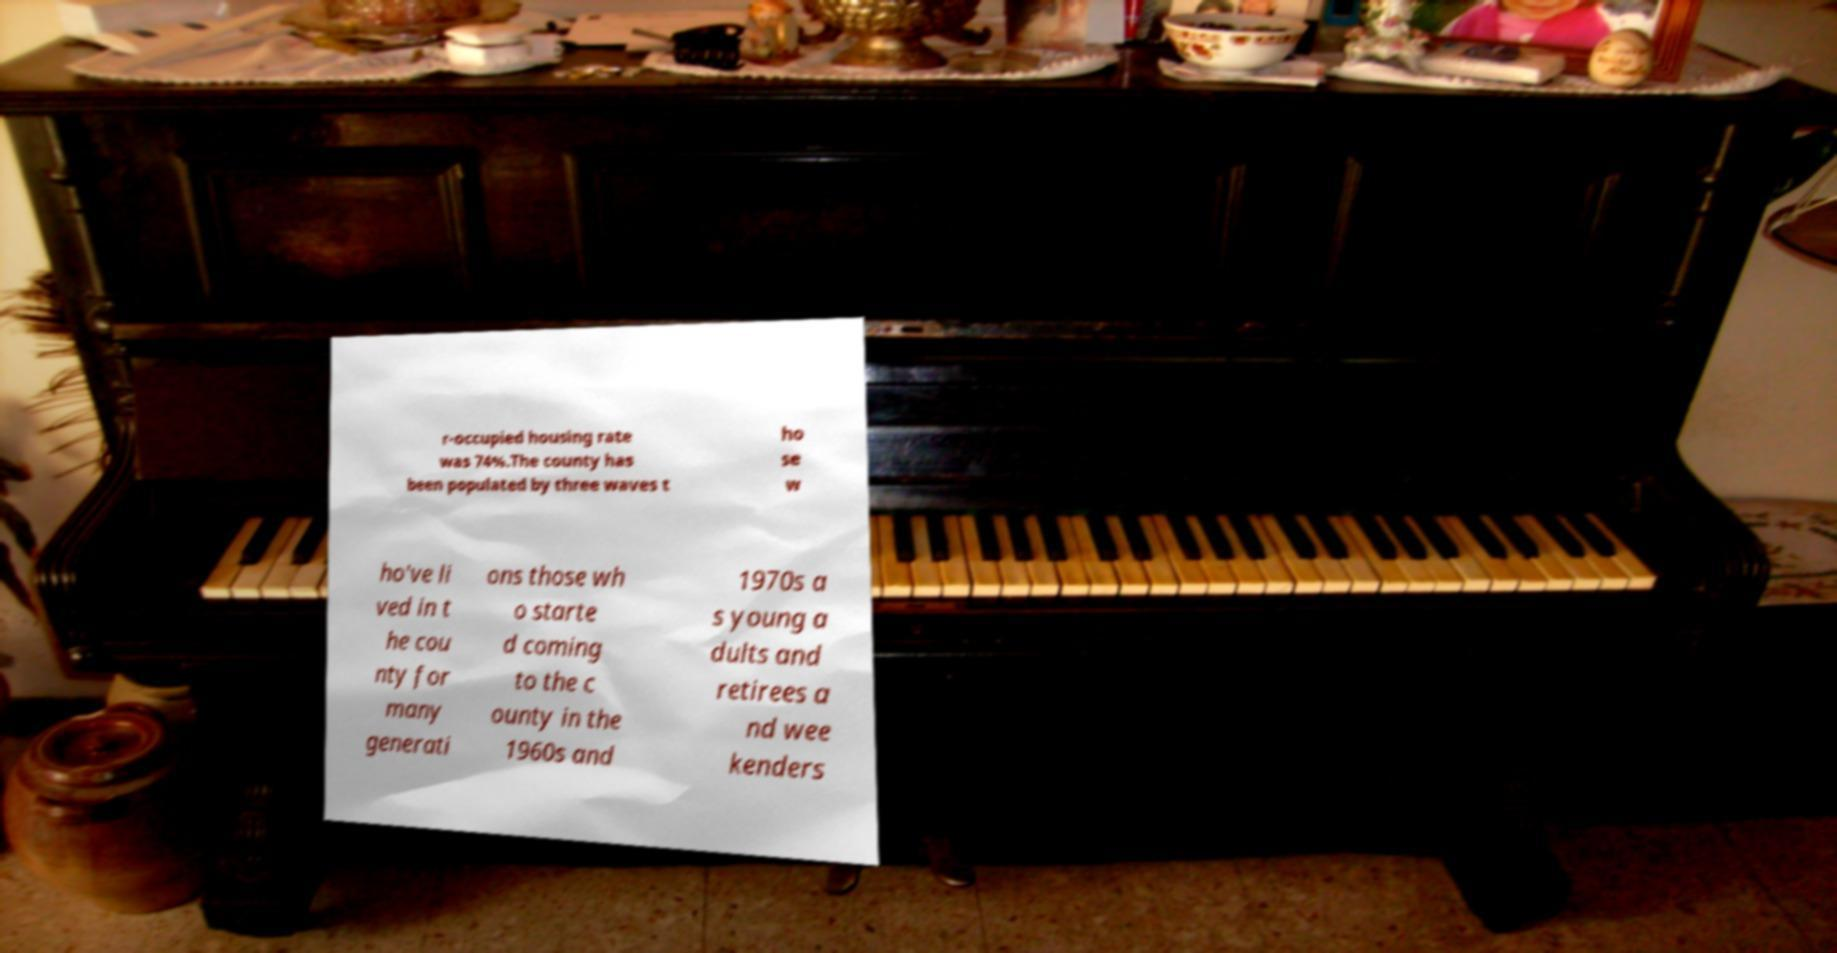Could you assist in decoding the text presented in this image and type it out clearly? r-occupied housing rate was 74%.The county has been populated by three waves t ho se w ho've li ved in t he cou nty for many generati ons those wh o starte d coming to the c ounty in the 1960s and 1970s a s young a dults and retirees a nd wee kenders 